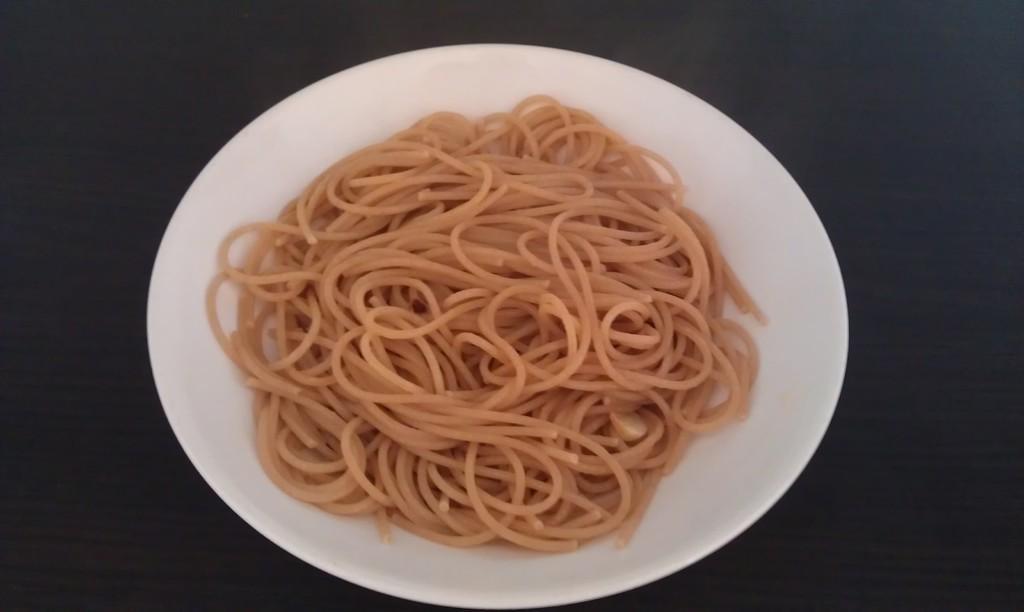In one or two sentences, can you explain what this image depicts? In the foreground of this image, there are noodles in a white bowl on the black surface. 